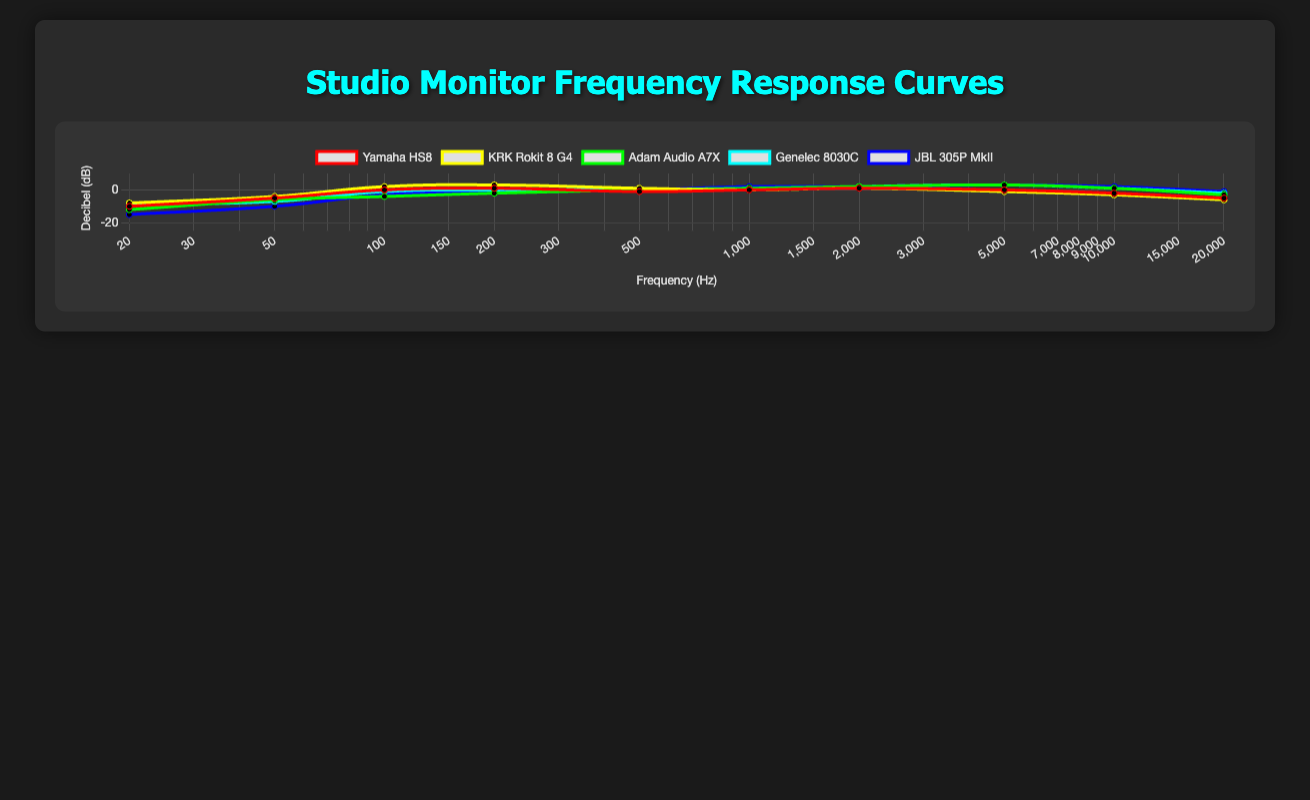Which studio monitor has the flattest frequency response curve? To determine which monitor has the flattest frequency response, observe the frequency response curves and identify the one with the least variation in decibel levels across the frequency range. The Genelec 8030C maintains a relatively stable response with minimal deviations.
Answer: Genelec 8030C Which monitor has the highest decibel level at 100 Hz? Look at the 100 Hz data points for each monitor and compare the decibel levels. The KRK Rokit 8 G4 has the highest decibel level at 100 Hz, with a reading of 2 dB.
Answer: KRK Rokit 8 G4 At around 5000 Hz, how do the decibel levels of the Yamaha HS8 and the Adam Audio A7X compare? Locate the 5000 Hz frequency on both curves and compare their respective decibel levels. The Yamaha HS8 has 0 dB while the Adam Audio A7X has 3 dB. Therefore, the Adam Audio A7X is 3 dB higher at 5000 Hz.
Answer: Adam Audio A7X is 3 dB higher What is the average decibel level of the Yamaha HS8 at frequencies of 200 Hz, 1000 Hz, and 2000 Hz? Sum the decibel levels at these frequencies for the Yamaha HS8: 1 (200 Hz) + 0 (1000 Hz) + 1 (2000 Hz) = 2. Then, calculate the average: 2 / 3 = 0.67 dB.
Answer: 0.67 dB Which monitor exhibits the greatest drop in decibels from 20 Hz to 20000 Hz? Calculate the difference in decibel levels between 20 Hz and 20000 Hz for each monitor. Compare these differences to find the greatest drop. The JBL 305P MkII exhibits the greatest drop: -15 dB (20 Hz) to -1 dB (20000 Hz) equals a 14 dB drop.
Answer: JBL 305P MkII Among the monitors listed, which one shows a rise in decibels at high frequencies (10000 Hz)? Examine the decibel values at 10000 Hz for any upward trend. The JBL 305P MkII shows an upward trend as it has 2 dB at 10000 Hz.
Answer: JBL 305P MkII 